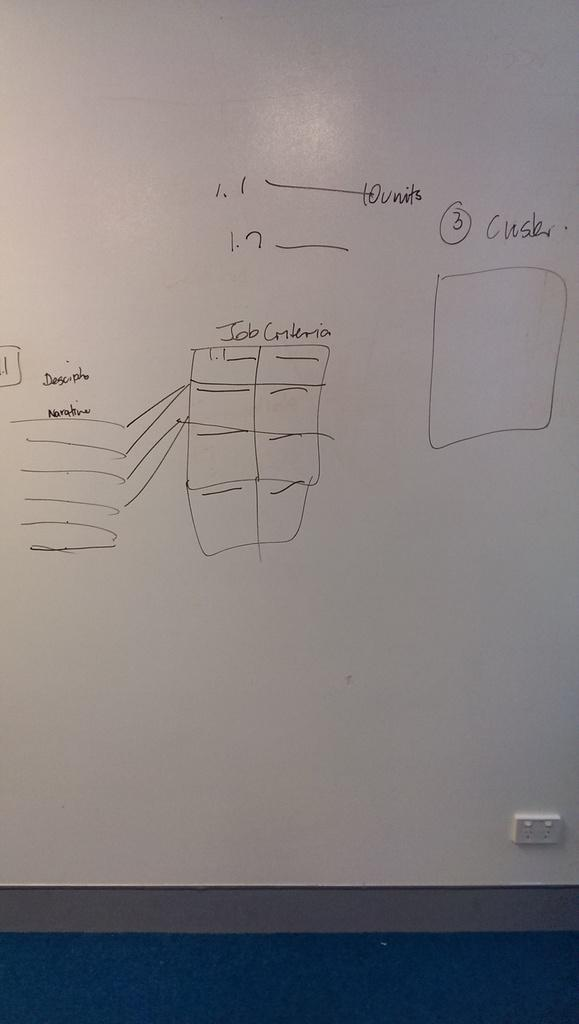<image>
Give a short and clear explanation of the subsequent image. A grid of boxes is labeled "job criteria" on the whiteboard. 